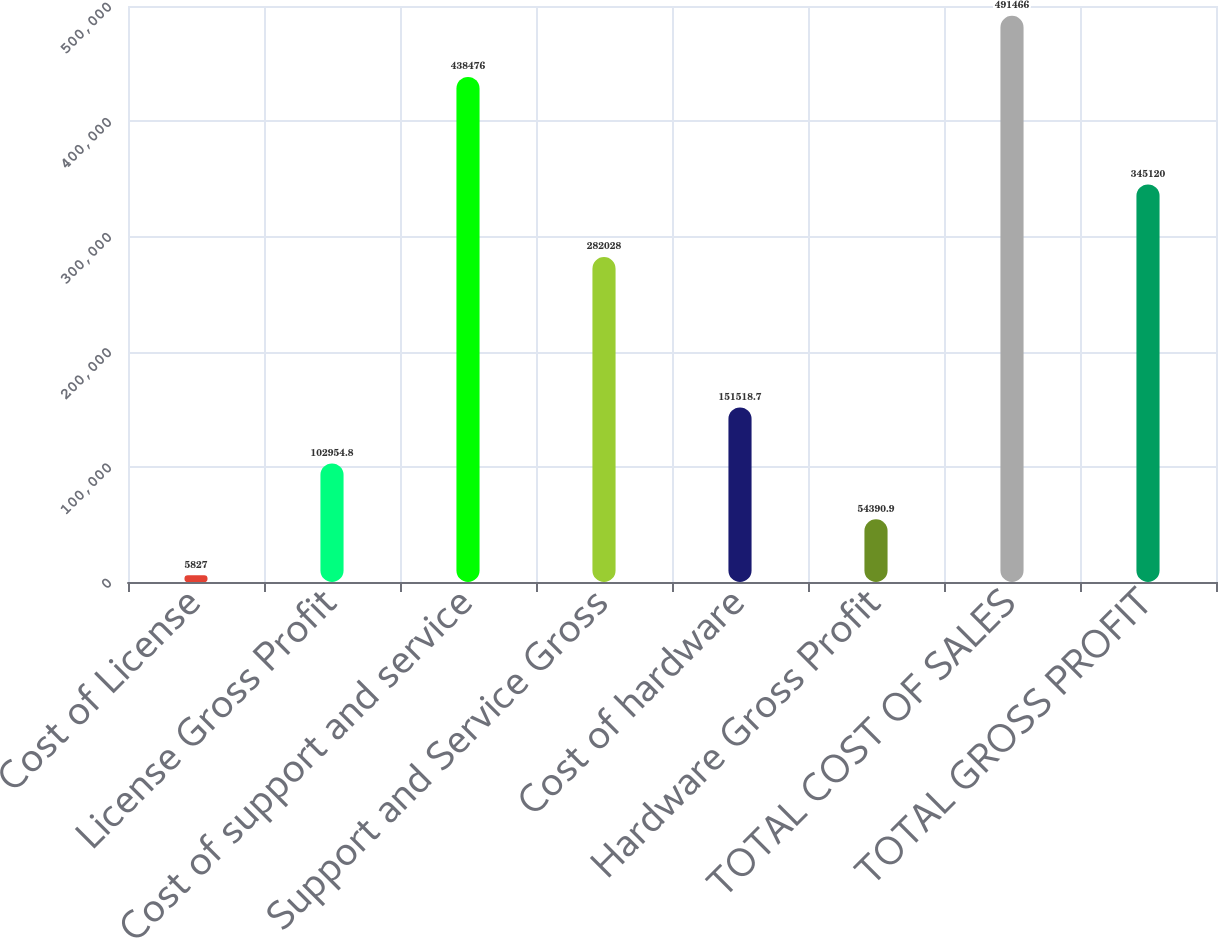Convert chart to OTSL. <chart><loc_0><loc_0><loc_500><loc_500><bar_chart><fcel>Cost of License<fcel>License Gross Profit<fcel>Cost of support and service<fcel>Support and Service Gross<fcel>Cost of hardware<fcel>Hardware Gross Profit<fcel>TOTAL COST OF SALES<fcel>TOTAL GROSS PROFIT<nl><fcel>5827<fcel>102955<fcel>438476<fcel>282028<fcel>151519<fcel>54390.9<fcel>491466<fcel>345120<nl></chart> 